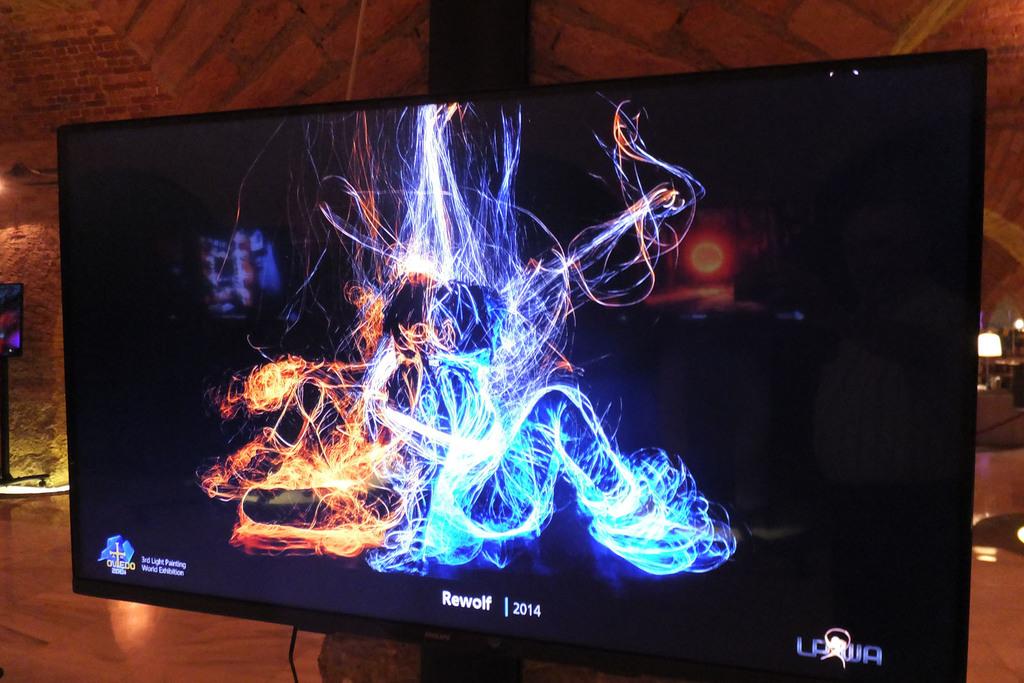What is the year mentioned on the tv screen?
Your answer should be compact. 2014. 